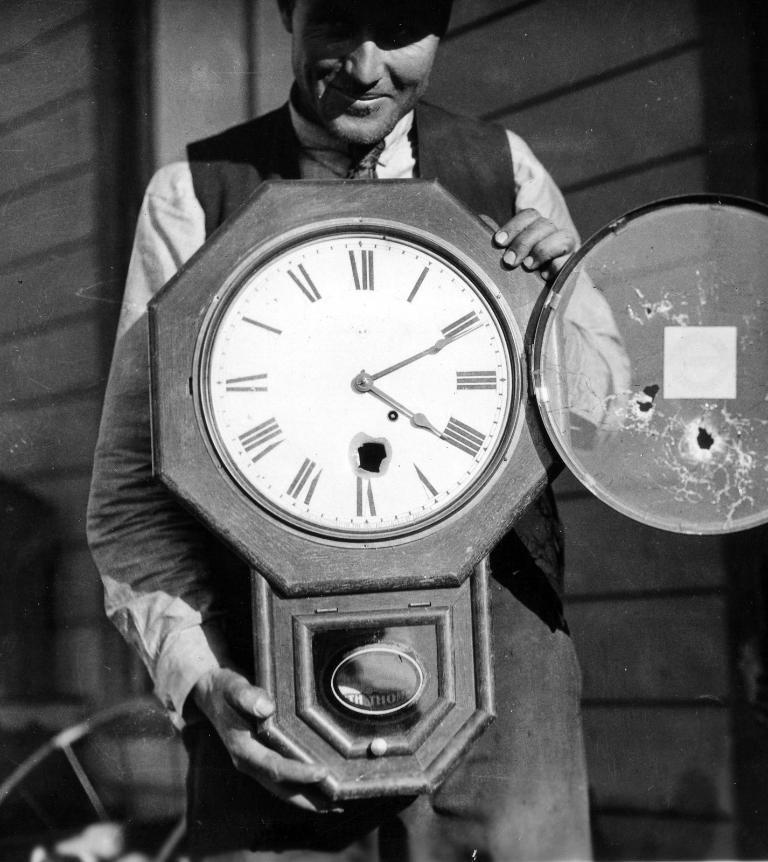<image>
Create a compact narrative representing the image presented. A man holding up an open Roman numeral clock with a bullet hole right above the VI numeral. 